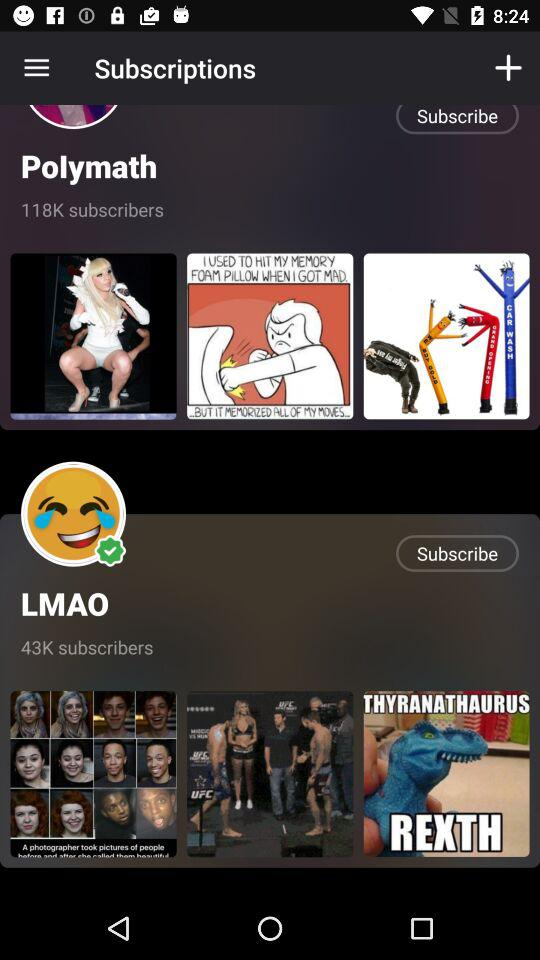How many people subscribe to Polymath? There are 118K people who subscribe to Polymath. 